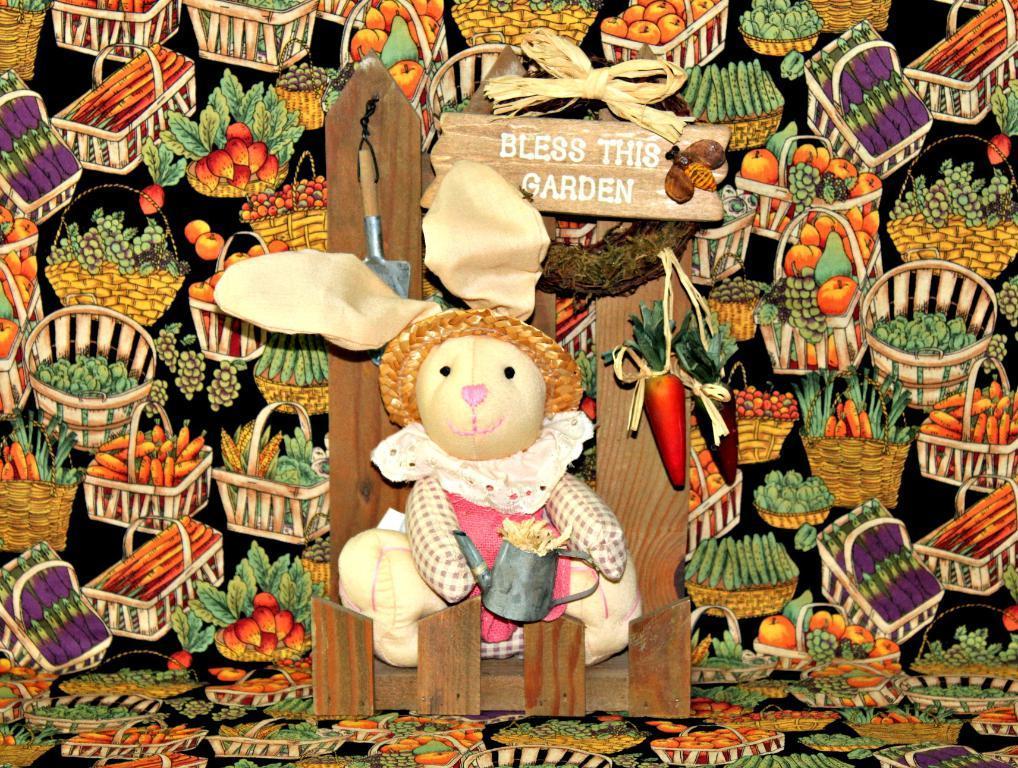Could you give a brief overview of what you see in this image? In the center of this picture we can see a soft toy wearing pink color dress, holding some object and sitting on a couch and we can see there are some objects hanging on the wooden object. In the background we can see the pictures of baskets containing fruits and vegetables and we can see the picture of an insect on the wooden board and we can see the text on the board. 